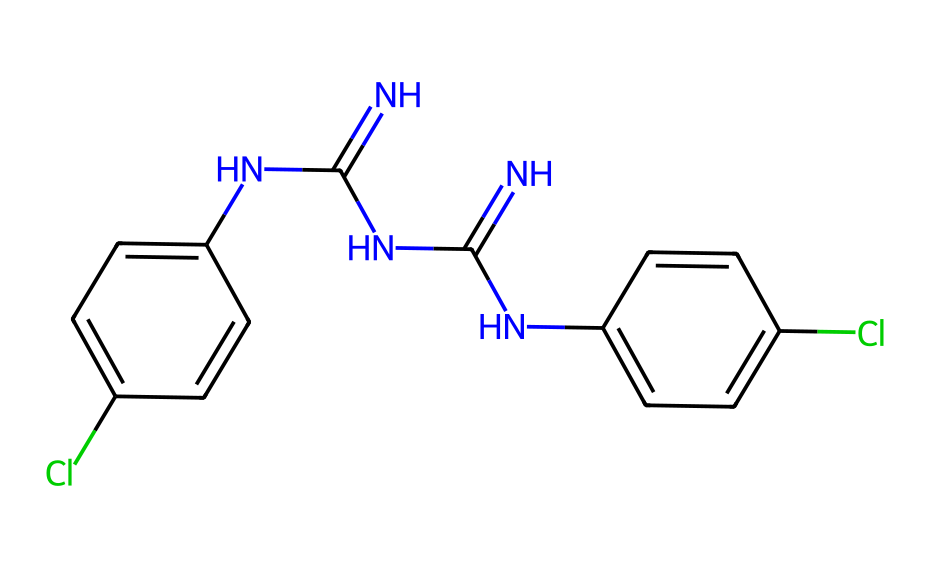What is the name of this chemical? The SMILES representation indicates a chemical with chlorinated phenyl rings and multiple nitrogen-containing groups, which is known as chlorhexidine.
Answer: chlorhexidine How many chlorine atoms are present? By analyzing the structure, there are two chlorine atoms indicated by 'Cl' in the SMILES.
Answer: two What type of chemical bonding is primarily present? The structure contains both covalent bonds (between carbon and nitrogen) and ionic character due to the presence of chlorines, but primarily covalent bonds are indicative of this molecule.
Answer: covalent How many nitrogen atoms are in the structure? The SMILES representation includes multiple 'N' letters, indicating a total of four nitrogen atoms present in the structure.
Answer: four What is the molecular formula's primary functional group in this lubricant? The presence of nitrogen within amine groups (the -NH groups) suggests that chlorhexidine has primary amine functionalities contributing to its antiseptic properties.
Answer: amine Why is chlorhexidine useful in lubricating solutions? Chlorhexidine is effective due to its antiseptic properties which prevent infection, making it suitable for use in lubricating solutions that require sterility.
Answer: antiseptic 